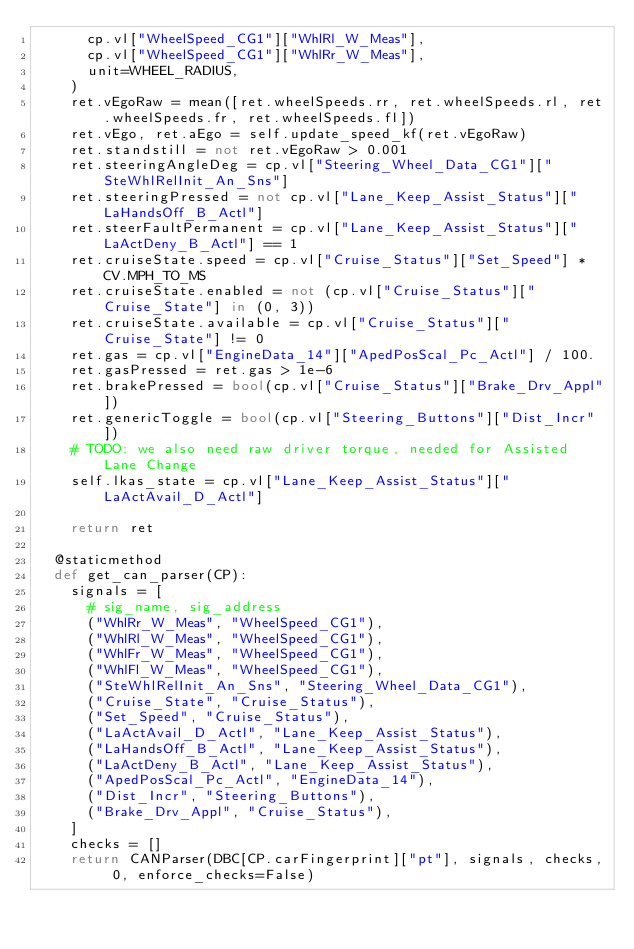<code> <loc_0><loc_0><loc_500><loc_500><_Python_>      cp.vl["WheelSpeed_CG1"]["WhlRl_W_Meas"],
      cp.vl["WheelSpeed_CG1"]["WhlRr_W_Meas"],
      unit=WHEEL_RADIUS,
    )
    ret.vEgoRaw = mean([ret.wheelSpeeds.rr, ret.wheelSpeeds.rl, ret.wheelSpeeds.fr, ret.wheelSpeeds.fl])
    ret.vEgo, ret.aEgo = self.update_speed_kf(ret.vEgoRaw)
    ret.standstill = not ret.vEgoRaw > 0.001
    ret.steeringAngleDeg = cp.vl["Steering_Wheel_Data_CG1"]["SteWhlRelInit_An_Sns"]
    ret.steeringPressed = not cp.vl["Lane_Keep_Assist_Status"]["LaHandsOff_B_Actl"]
    ret.steerFaultPermanent = cp.vl["Lane_Keep_Assist_Status"]["LaActDeny_B_Actl"] == 1
    ret.cruiseState.speed = cp.vl["Cruise_Status"]["Set_Speed"] * CV.MPH_TO_MS
    ret.cruiseState.enabled = not (cp.vl["Cruise_Status"]["Cruise_State"] in (0, 3))
    ret.cruiseState.available = cp.vl["Cruise_Status"]["Cruise_State"] != 0
    ret.gas = cp.vl["EngineData_14"]["ApedPosScal_Pc_Actl"] / 100.
    ret.gasPressed = ret.gas > 1e-6
    ret.brakePressed = bool(cp.vl["Cruise_Status"]["Brake_Drv_Appl"])
    ret.genericToggle = bool(cp.vl["Steering_Buttons"]["Dist_Incr"])
    # TODO: we also need raw driver torque, needed for Assisted Lane Change
    self.lkas_state = cp.vl["Lane_Keep_Assist_Status"]["LaActAvail_D_Actl"]

    return ret

  @staticmethod
  def get_can_parser(CP):
    signals = [
      # sig_name, sig_address
      ("WhlRr_W_Meas", "WheelSpeed_CG1"),
      ("WhlRl_W_Meas", "WheelSpeed_CG1"),
      ("WhlFr_W_Meas", "WheelSpeed_CG1"),
      ("WhlFl_W_Meas", "WheelSpeed_CG1"),
      ("SteWhlRelInit_An_Sns", "Steering_Wheel_Data_CG1"),
      ("Cruise_State", "Cruise_Status"),
      ("Set_Speed", "Cruise_Status"),
      ("LaActAvail_D_Actl", "Lane_Keep_Assist_Status"),
      ("LaHandsOff_B_Actl", "Lane_Keep_Assist_Status"),
      ("LaActDeny_B_Actl", "Lane_Keep_Assist_Status"),
      ("ApedPosScal_Pc_Actl", "EngineData_14"),
      ("Dist_Incr", "Steering_Buttons"),
      ("Brake_Drv_Appl", "Cruise_Status"),
    ]
    checks = []
    return CANParser(DBC[CP.carFingerprint]["pt"], signals, checks, 0, enforce_checks=False)
</code> 